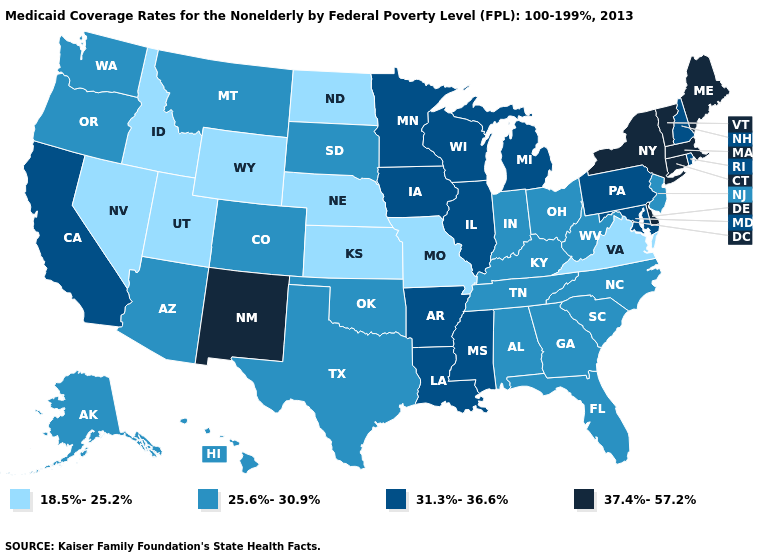Does New Mexico have a lower value than Montana?
Keep it brief. No. What is the value of North Dakota?
Concise answer only. 18.5%-25.2%. Name the states that have a value in the range 31.3%-36.6%?
Keep it brief. Arkansas, California, Illinois, Iowa, Louisiana, Maryland, Michigan, Minnesota, Mississippi, New Hampshire, Pennsylvania, Rhode Island, Wisconsin. Which states have the lowest value in the USA?
Answer briefly. Idaho, Kansas, Missouri, Nebraska, Nevada, North Dakota, Utah, Virginia, Wyoming. What is the value of Maryland?
Answer briefly. 31.3%-36.6%. Does Missouri have the lowest value in the USA?
Concise answer only. Yes. Does North Dakota have the lowest value in the USA?
Quick response, please. Yes. Among the states that border Oregon , which have the highest value?
Short answer required. California. Among the states that border Nevada , does Idaho have the highest value?
Give a very brief answer. No. What is the value of North Carolina?
Answer briefly. 25.6%-30.9%. Does the map have missing data?
Keep it brief. No. How many symbols are there in the legend?
Keep it brief. 4. Which states have the lowest value in the USA?
Keep it brief. Idaho, Kansas, Missouri, Nebraska, Nevada, North Dakota, Utah, Virginia, Wyoming. What is the value of Louisiana?
Give a very brief answer. 31.3%-36.6%. What is the value of Texas?
Answer briefly. 25.6%-30.9%. 